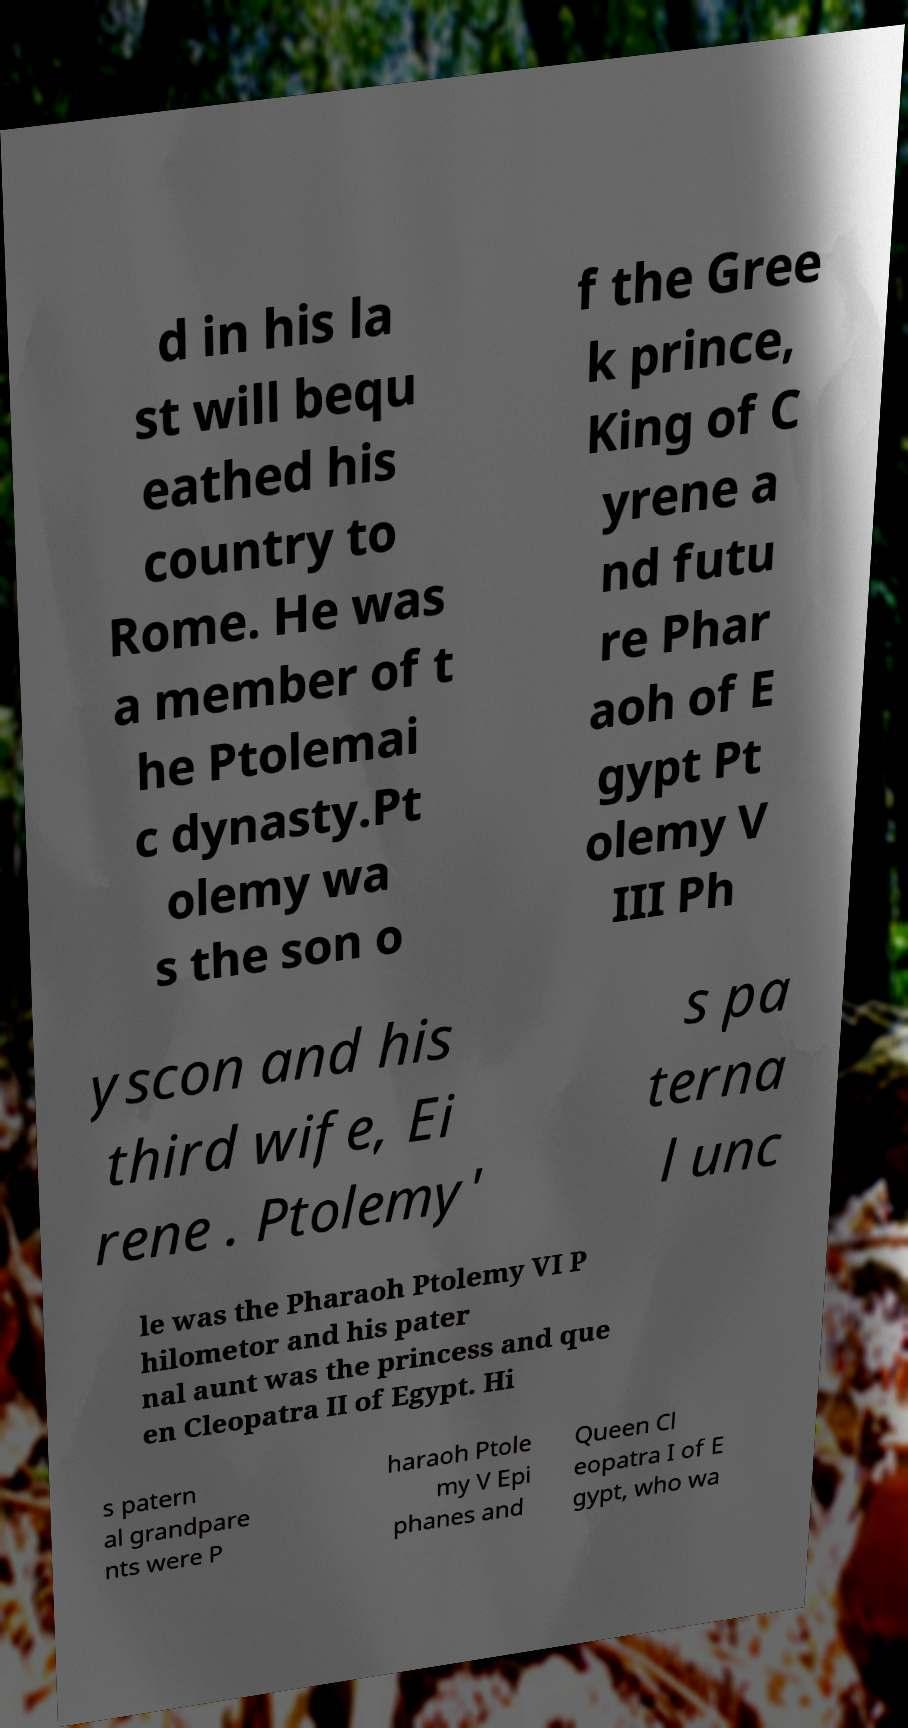For documentation purposes, I need the text within this image transcribed. Could you provide that? d in his la st will bequ eathed his country to Rome. He was a member of t he Ptolemai c dynasty.Pt olemy wa s the son o f the Gree k prince, King of C yrene a nd futu re Phar aoh of E gypt Pt olemy V III Ph yscon and his third wife, Ei rene . Ptolemy' s pa terna l unc le was the Pharaoh Ptolemy VI P hilometor and his pater nal aunt was the princess and que en Cleopatra II of Egypt. Hi s patern al grandpare nts were P haraoh Ptole my V Epi phanes and Queen Cl eopatra I of E gypt, who wa 